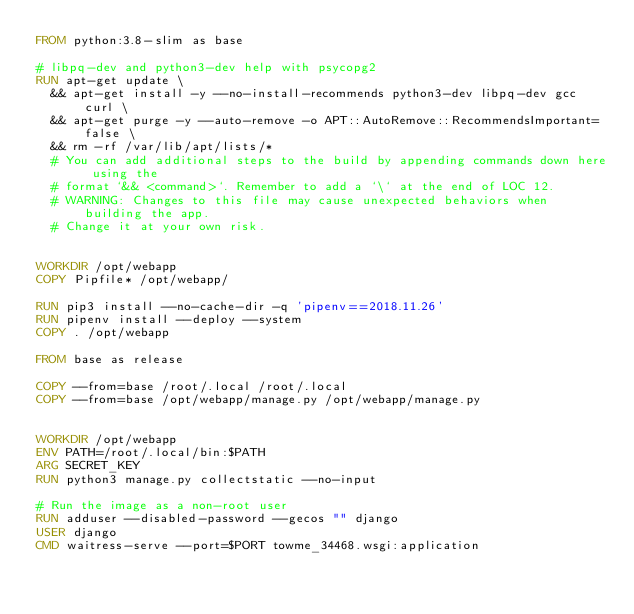<code> <loc_0><loc_0><loc_500><loc_500><_Dockerfile_>FROM python:3.8-slim as base

# libpq-dev and python3-dev help with psycopg2
RUN apt-get update \
  && apt-get install -y --no-install-recommends python3-dev libpq-dev gcc curl \
  && apt-get purge -y --auto-remove -o APT::AutoRemove::RecommendsImportant=false \
  && rm -rf /var/lib/apt/lists/*
  # You can add additional steps to the build by appending commands down here using the
  # format `&& <command>`. Remember to add a `\` at the end of LOC 12.
  # WARNING: Changes to this file may cause unexpected behaviors when building the app.
  # Change it at your own risk.


WORKDIR /opt/webapp
COPY Pipfile* /opt/webapp/

RUN pip3 install --no-cache-dir -q 'pipenv==2018.11.26' 
RUN pipenv install --deploy --system
COPY . /opt/webapp

FROM base as release

COPY --from=base /root/.local /root/.local
COPY --from=base /opt/webapp/manage.py /opt/webapp/manage.py


WORKDIR /opt/webapp
ENV PATH=/root/.local/bin:$PATH
ARG SECRET_KEY 
RUN python3 manage.py collectstatic --no-input

# Run the image as a non-root user
RUN adduser --disabled-password --gecos "" django
USER django
CMD waitress-serve --port=$PORT towme_34468.wsgi:application
</code> 